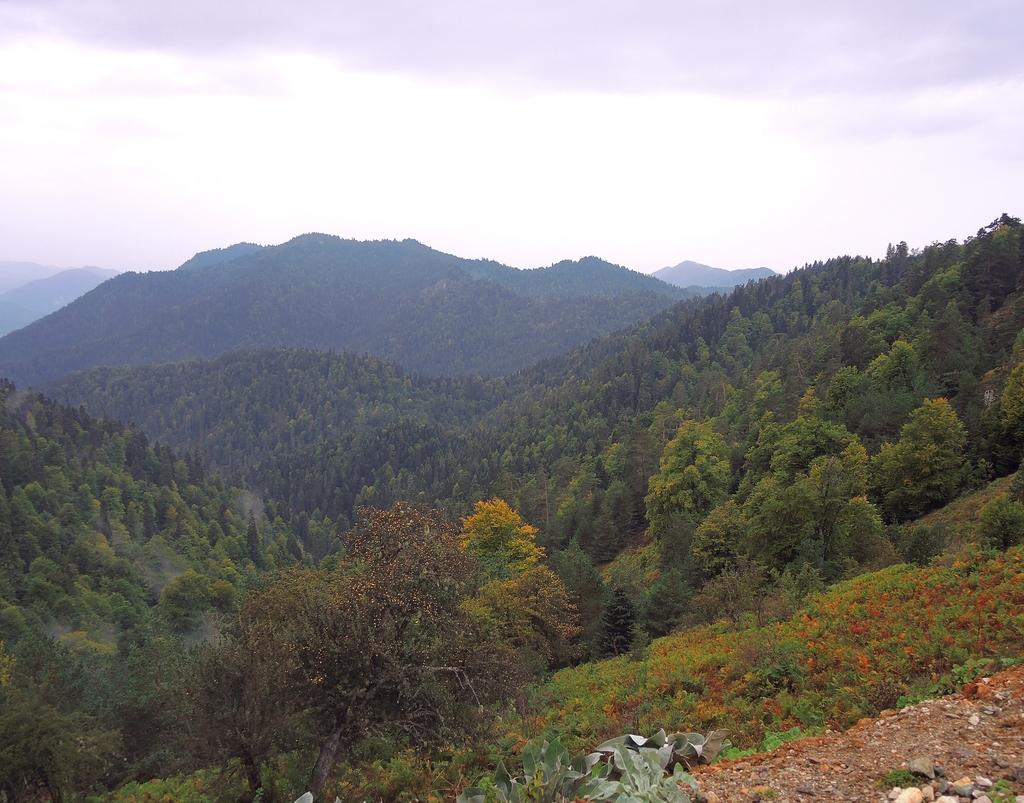What type of vegetation can be seen in the image? There are trees in the image. What can be seen in the distance in the image? There are hills in the background of the image. What is visible in the sky in the background of the image? There are clouds in the sky in the background of the image. What type of business is being conducted in the image? There is no indication of any business activity in the image; it primarily features trees, hills, and clouds. 